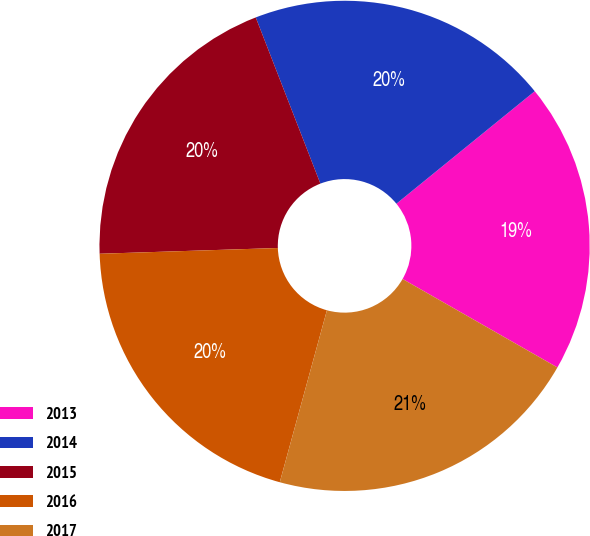Convert chart to OTSL. <chart><loc_0><loc_0><loc_500><loc_500><pie_chart><fcel>2013<fcel>2014<fcel>2015<fcel>2016<fcel>2017<nl><fcel>19.13%<fcel>20.04%<fcel>19.61%<fcel>20.23%<fcel>21.0%<nl></chart> 